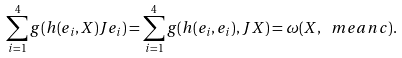<formula> <loc_0><loc_0><loc_500><loc_500>\sum _ { i = 1 } ^ { 4 } g ( h ( e _ { i } , X ) J e _ { i } ) = \sum _ { i = 1 } ^ { 4 } g ( h ( e _ { i } , e _ { i } ) , J X ) = \omega ( X , \ m e a n c ) .</formula> 